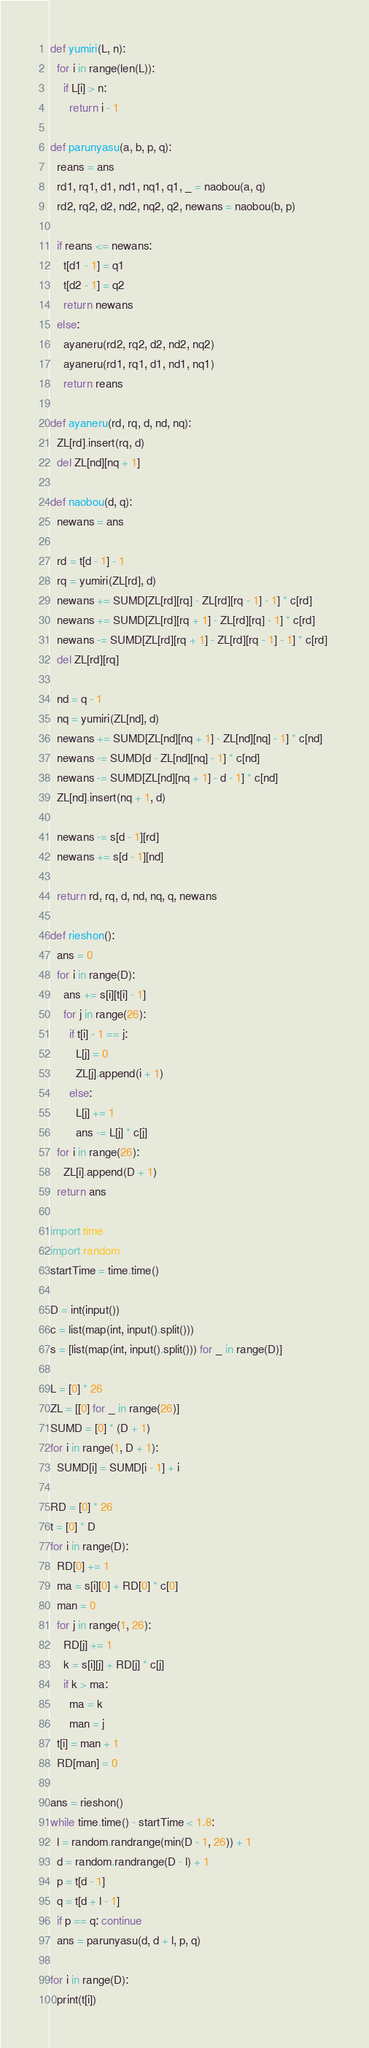<code> <loc_0><loc_0><loc_500><loc_500><_Python_>def yumiri(L, n):
  for i in range(len(L)):
    if L[i] > n:
      return i - 1

def parunyasu(a, b, p, q):
  reans = ans
  rd1, rq1, d1, nd1, nq1, q1, _ = naobou(a, q)
  rd2, rq2, d2, nd2, nq2, q2, newans = naobou(b, p)

  if reans <= newans:
    t[d1 - 1] = q1
    t[d2 - 1] = q2
    return newans
  else:
    ayaneru(rd2, rq2, d2, nd2, nq2)
    ayaneru(rd1, rq1, d1, nd1, nq1)
    return reans

def ayaneru(rd, rq, d, nd, nq):
  ZL[rd].insert(rq, d)
  del ZL[nd][nq + 1]

def naobou(d, q):
  newans = ans

  rd = t[d - 1] - 1
  rq = yumiri(ZL[rd], d)
  newans += SUMD[ZL[rd][rq] - ZL[rd][rq - 1] - 1] * c[rd]
  newans += SUMD[ZL[rd][rq + 1] - ZL[rd][rq] - 1] * c[rd]
  newans -= SUMD[ZL[rd][rq + 1] - ZL[rd][rq - 1] - 1] * c[rd] 
  del ZL[rd][rq]

  nd = q - 1
  nq = yumiri(ZL[nd], d)
  newans += SUMD[ZL[nd][nq + 1] - ZL[nd][nq] - 1] * c[nd]
  newans -= SUMD[d - ZL[nd][nq] - 1] * c[nd]
  newans -= SUMD[ZL[nd][nq + 1] - d - 1] * c[nd]
  ZL[nd].insert(nq + 1, d)

  newans -= s[d - 1][rd]
  newans += s[d - 1][nd]

  return rd, rq, d, nd, nq, q, newans

def rieshon():
  ans = 0
  for i in range(D):
    ans += s[i][t[i] - 1]
    for j in range(26):
      if t[i] - 1 == j:
        L[j] = 0
        ZL[j].append(i + 1)
      else:
        L[j] += 1
        ans -= L[j] * c[j]
  for i in range(26):
    ZL[i].append(D + 1)
  return ans

import time
import random
startTime = time.time()

D = int(input())
c = list(map(int, input().split()))
s = [list(map(int, input().split())) for _ in range(D)]

L = [0] * 26
ZL = [[0] for _ in range(26)]
SUMD = [0] * (D + 1)
for i in range(1, D + 1):
  SUMD[i] = SUMD[i - 1] + i

RD = [0] * 26
t = [0] * D
for i in range(D):
  RD[0] += 1
  ma = s[i][0] + RD[0] * c[0]
  man = 0
  for j in range(1, 26):
    RD[j] += 1
    k = s[i][j] + RD[j] * c[j]
    if k > ma:
      ma = k
      man = j
  t[i] = man + 1
  RD[man] = 0

ans = rieshon()
while time.time() - startTime < 1.8:
  l = random.randrange(min(D - 1, 26)) + 1
  d = random.randrange(D - l) + 1
  p = t[d - 1]
  q = t[d + l - 1]
  if p == q: continue
  ans = parunyasu(d, d + l, p, q)

for i in range(D):
  print(t[i])
</code> 